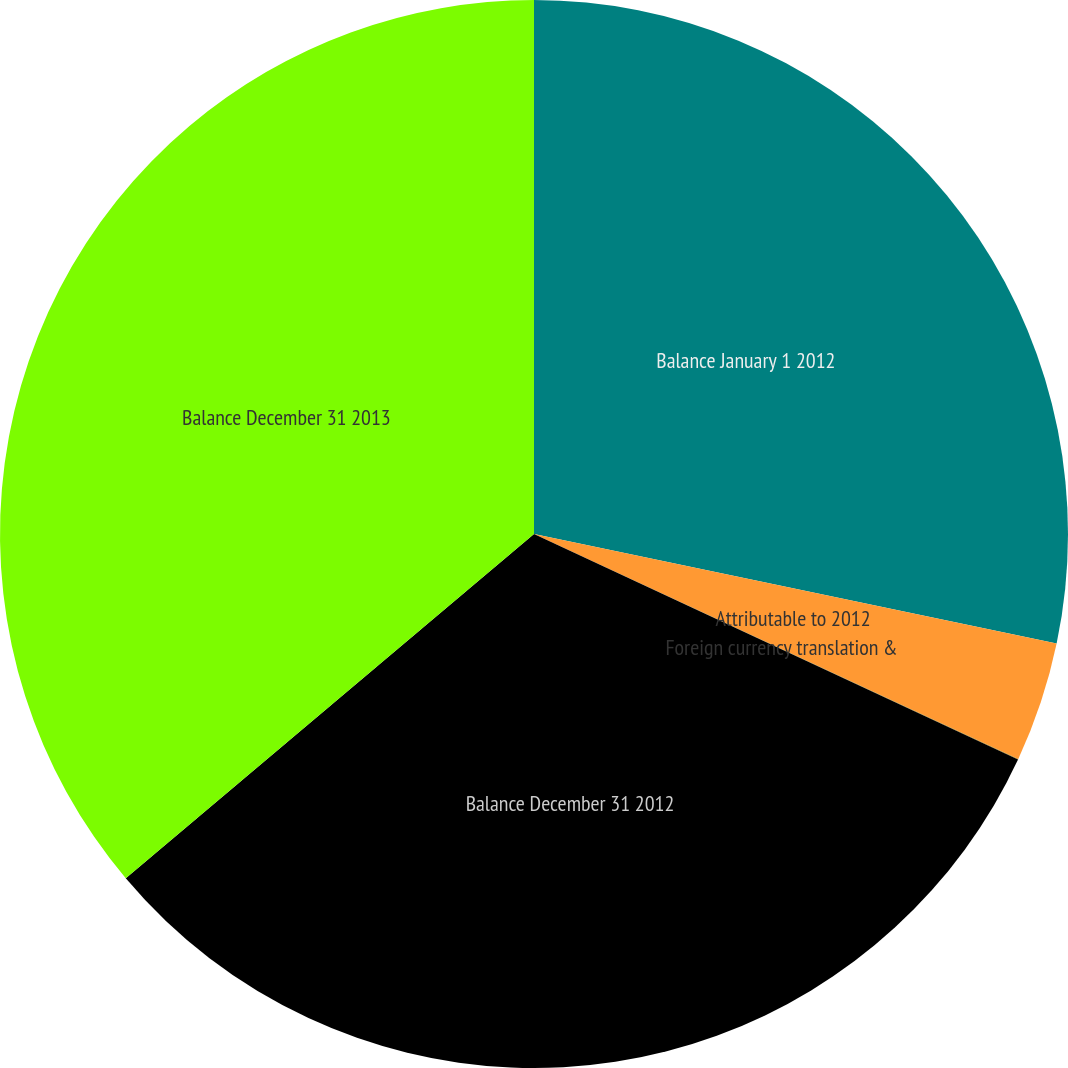Convert chart. <chart><loc_0><loc_0><loc_500><loc_500><pie_chart><fcel>Balance January 1 2012<fcel>Attributable to 2012<fcel>Foreign currency translation &<fcel>Balance December 31 2012<fcel>Balance December 31 2013<nl><fcel>28.29%<fcel>3.63%<fcel>0.02%<fcel>31.91%<fcel>36.15%<nl></chart> 